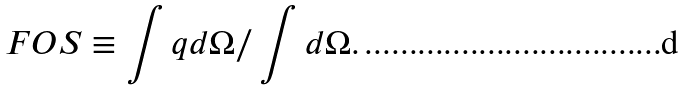<formula> <loc_0><loc_0><loc_500><loc_500>F O S \equiv \int q d \Omega / \int d \Omega .</formula> 